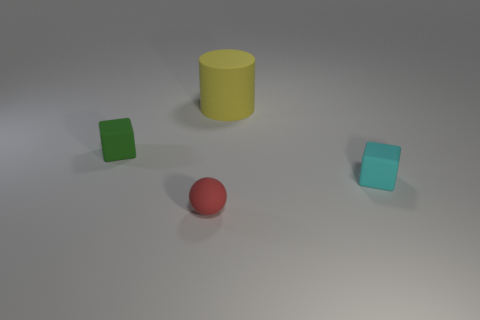Add 3 red balls. How many objects exist? 7 Subtract all spheres. How many objects are left? 3 Subtract 0 purple cubes. How many objects are left? 4 Subtract all small cyan things. Subtract all yellow cylinders. How many objects are left? 2 Add 1 big yellow cylinders. How many big yellow cylinders are left? 2 Add 2 tiny red rubber balls. How many tiny red rubber balls exist? 3 